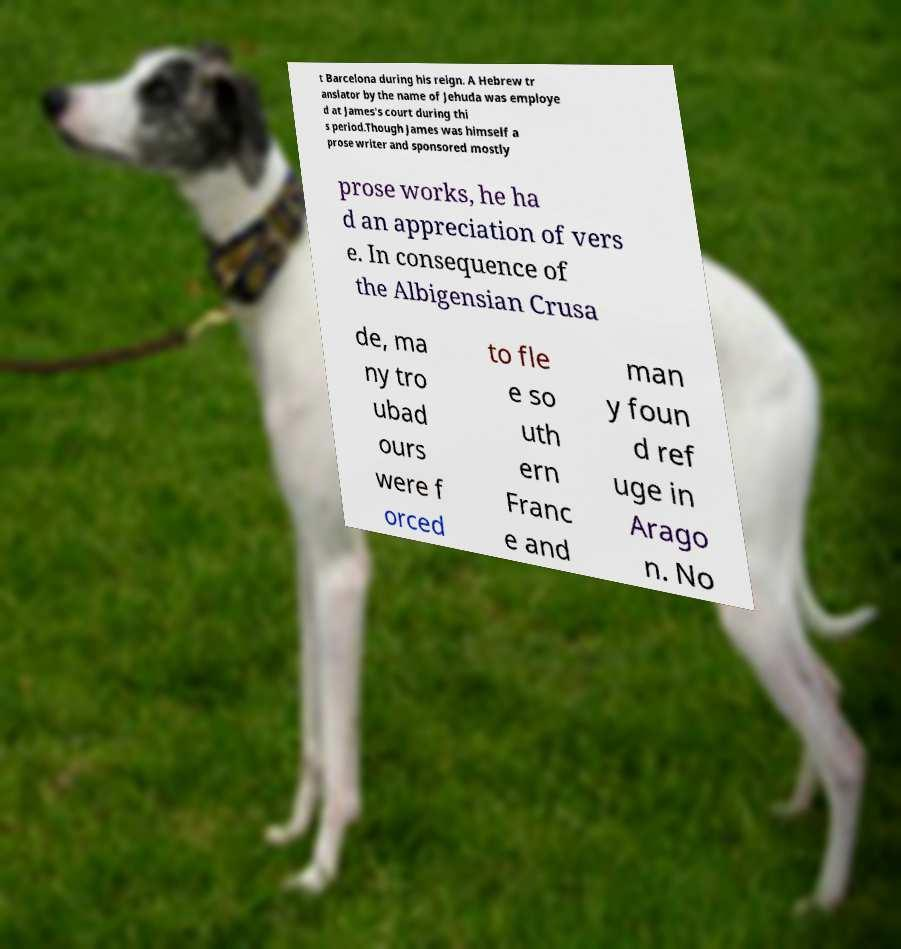What messages or text are displayed in this image? I need them in a readable, typed format. t Barcelona during his reign. A Hebrew tr anslator by the name of Jehuda was employe d at James's court during thi s period.Though James was himself a prose writer and sponsored mostly prose works, he ha d an appreciation of vers e. In consequence of the Albigensian Crusa de, ma ny tro ubad ours were f orced to fle e so uth ern Franc e and man y foun d ref uge in Arago n. No 